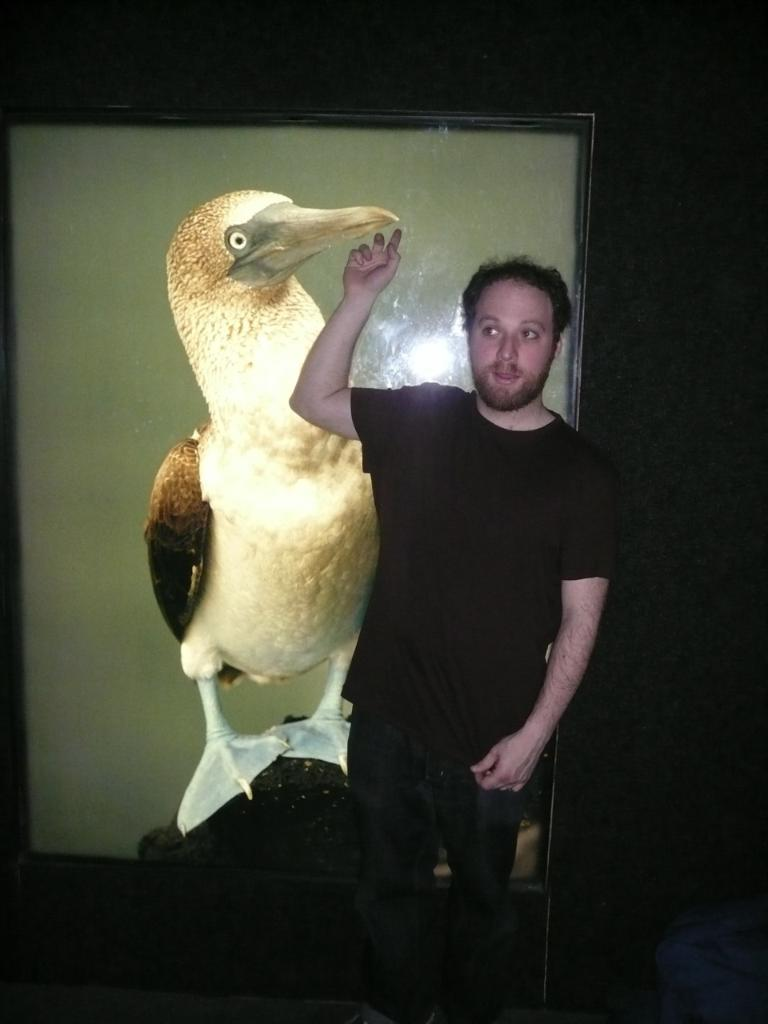What is the main subject in the front of the image? There is a man standing in the front of the image. Can you describe the man's facial expression? The man has an expression on his face. What can be seen in the background of the image? There is a drawing of a bird in the background of the image. How is the drawing of the bird displayed? The drawing is on a frame. What type of design is visible on the man's arm in the image? There is no mention of any design on the man's arm in the provided facts, so we cannot answer this question. 